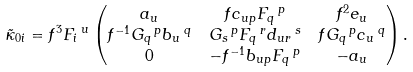Convert formula to latex. <formula><loc_0><loc_0><loc_500><loc_500>& \tilde { \kappa } _ { 0 i } = f ^ { 3 } F _ { i } \, ^ { u } \begin{pmatrix} a _ { u } & f c _ { u p } F _ { q } \, ^ { p } & f ^ { 2 } e _ { u } \\ f ^ { - 1 } G _ { q } \, ^ { p } b _ { u } \, ^ { q } & G _ { s } \, ^ { p } F _ { q } \, ^ { r } d _ { u r } \, ^ { s } & f G _ { q } \, ^ { p } c _ { u } \, ^ { q } \\ 0 & - f ^ { - 1 } b _ { u p } F _ { q } \, ^ { p } & - a _ { u } \end{pmatrix} .</formula> 